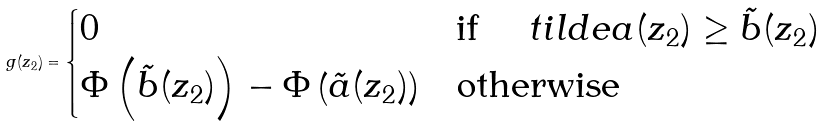Convert formula to latex. <formula><loc_0><loc_0><loc_500><loc_500>g ( z _ { 2 } ) = \begin{cases} 0 & \text {if } \quad t i l d e { a } ( z _ { 2 } ) \geq \tilde { b } ( z _ { 2 } ) \\ \Phi \left ( \tilde { b } ( z _ { 2 } ) \right ) - \Phi \left ( \tilde { a } ( z _ { 2 } ) \right ) & \text {otherwise} \end{cases}</formula> 